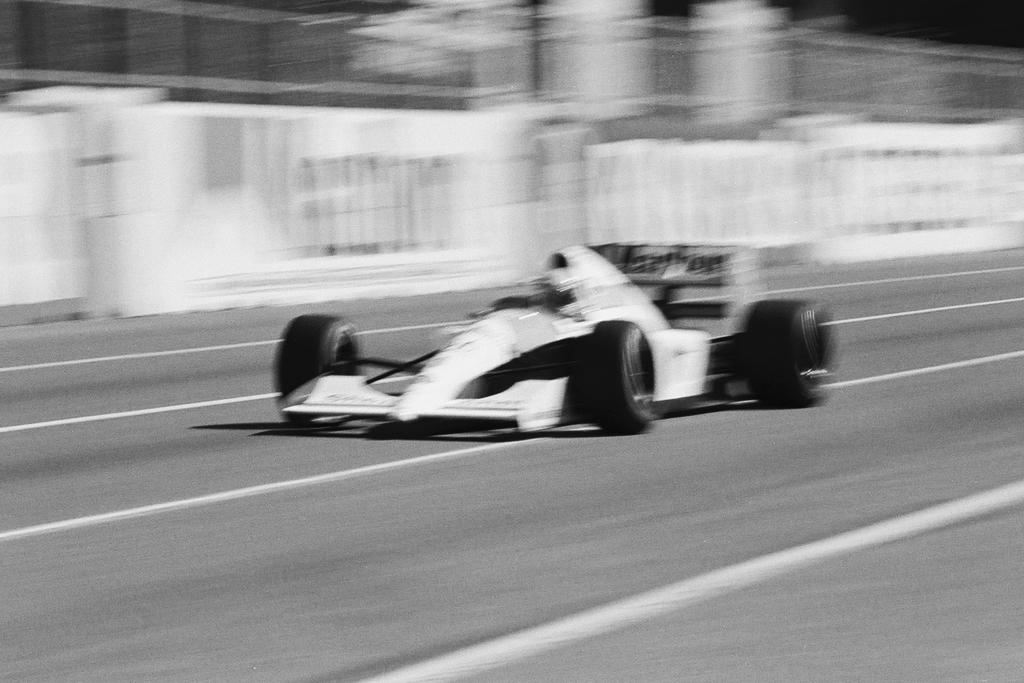What is the color scheme of the image? The image is black and white. What type of vehicle is in the image? There is a sport car in the image. Where is the sport car located? The sport car is on the road. What can be seen in the background of the image? There are banners in the background of the image. How does the sheet affect the movement of the planes in the image? There are no planes or sheets present in the image. 